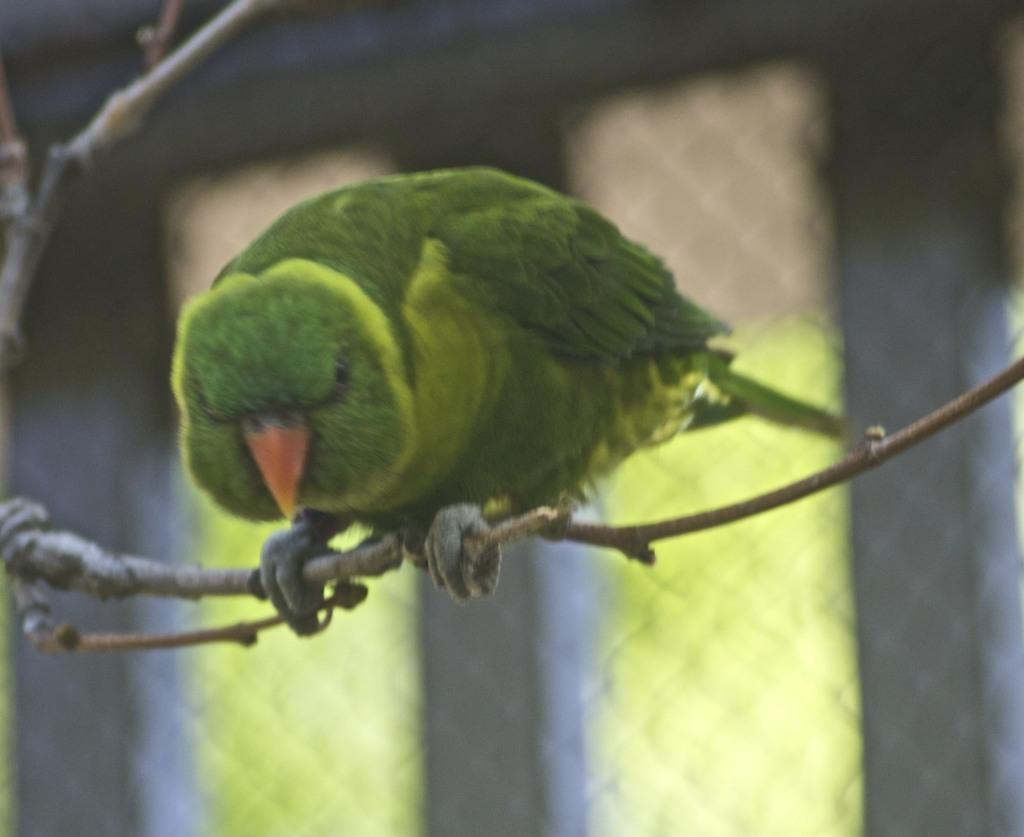What type of animal can be seen in the image? There is a bird in the image. Where is the bird located? The bird is on a branch. Can you describe the background of the image? The background of the image is blurred. What color is the bird? The bird is in green color. What type of linen is used to cover the bird's nest in the image? There is no mention of a bird's nest or linen in the image. 